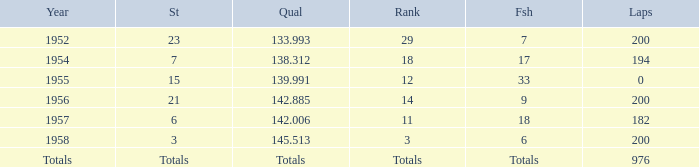What place did Jimmy Reece start from when he ranked 12? 15.0. 